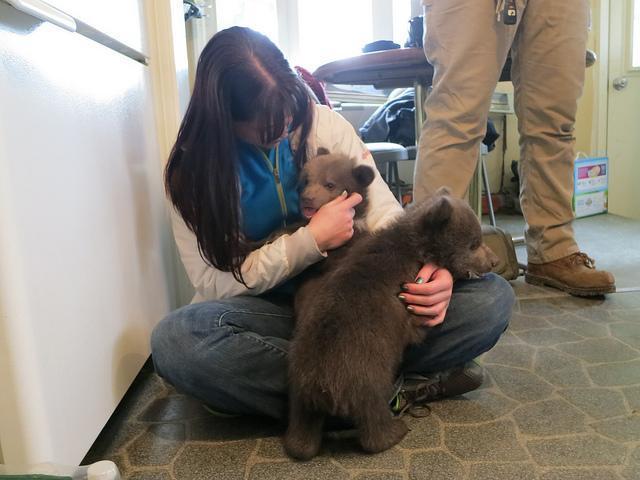The girl is playing with what animals?
Select the accurate response from the four choices given to answer the question.
Options: Skunks, lizards, cats, bears. Bears. 